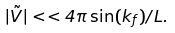<formula> <loc_0><loc_0><loc_500><loc_500>| \tilde { V } | < < 4 \pi \sin ( k _ { f } ) / L .</formula> 